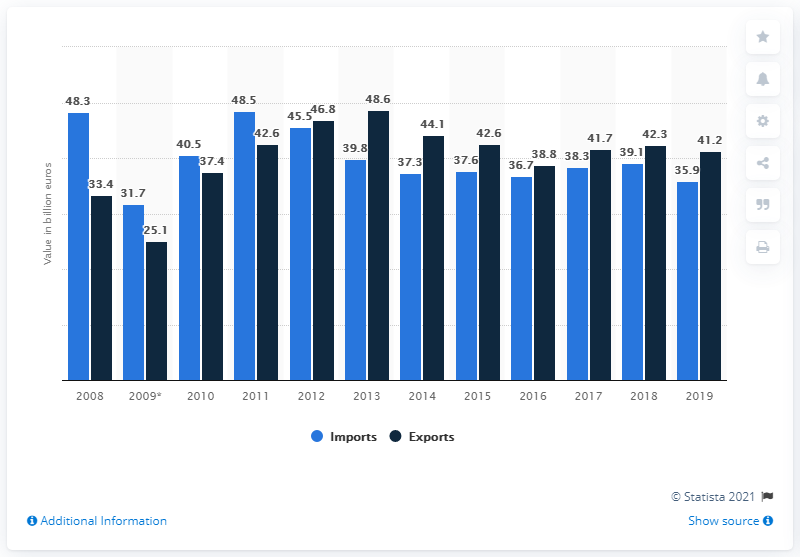Highlight a few significant elements in this photo. Exports from the 27 EU member countries to Mercosur countries totaled €41.2 billion in 2019. In 2019, the total value of European imports from Mercosur was 35.9 billion US dollars. 